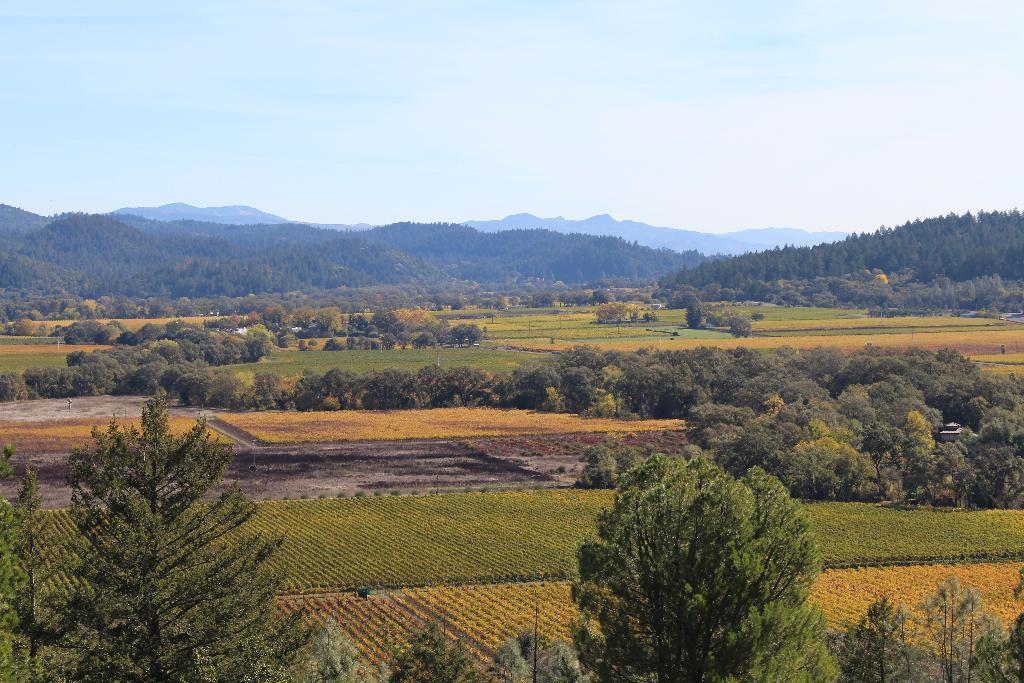What can be seen in the foreground of the image? There are trees and farming fields in the foreground of the image. What type of landscape feature is visible in the background of the image? There are mountains visible in the image. What part of the natural environment is visible in the image? The sky is visible in the image. What type of rock is being discussed by the trees in the image? There is no discussion or rock present in the image; it features trees and farming fields in the foreground, mountains in the background, and the sky. Can you see the elbow of the mountain in the image? There is no reference to an elbow in the image, as it features natural landscape elements such as trees, farming fields, mountains, and the sky. 